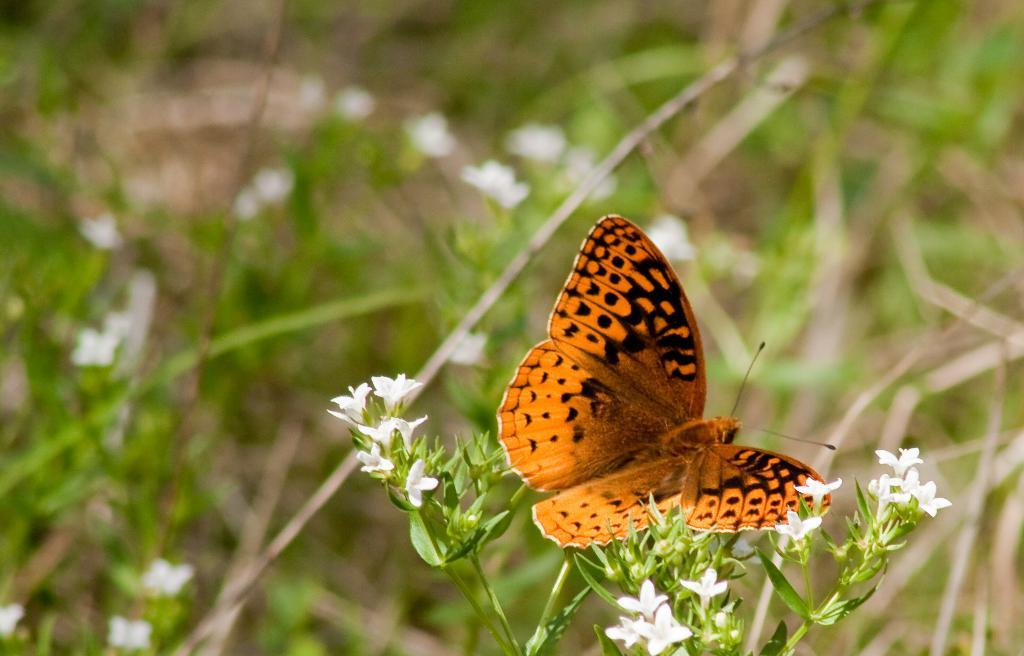What is on the plant in the image? There is a butterfly on a plant in the image. What can be seen in the background of the image? There are plants with white flowers in the background of the image. What type of thunder can be heard in the image? There is no thunder present in the image, as it is a still photograph. 